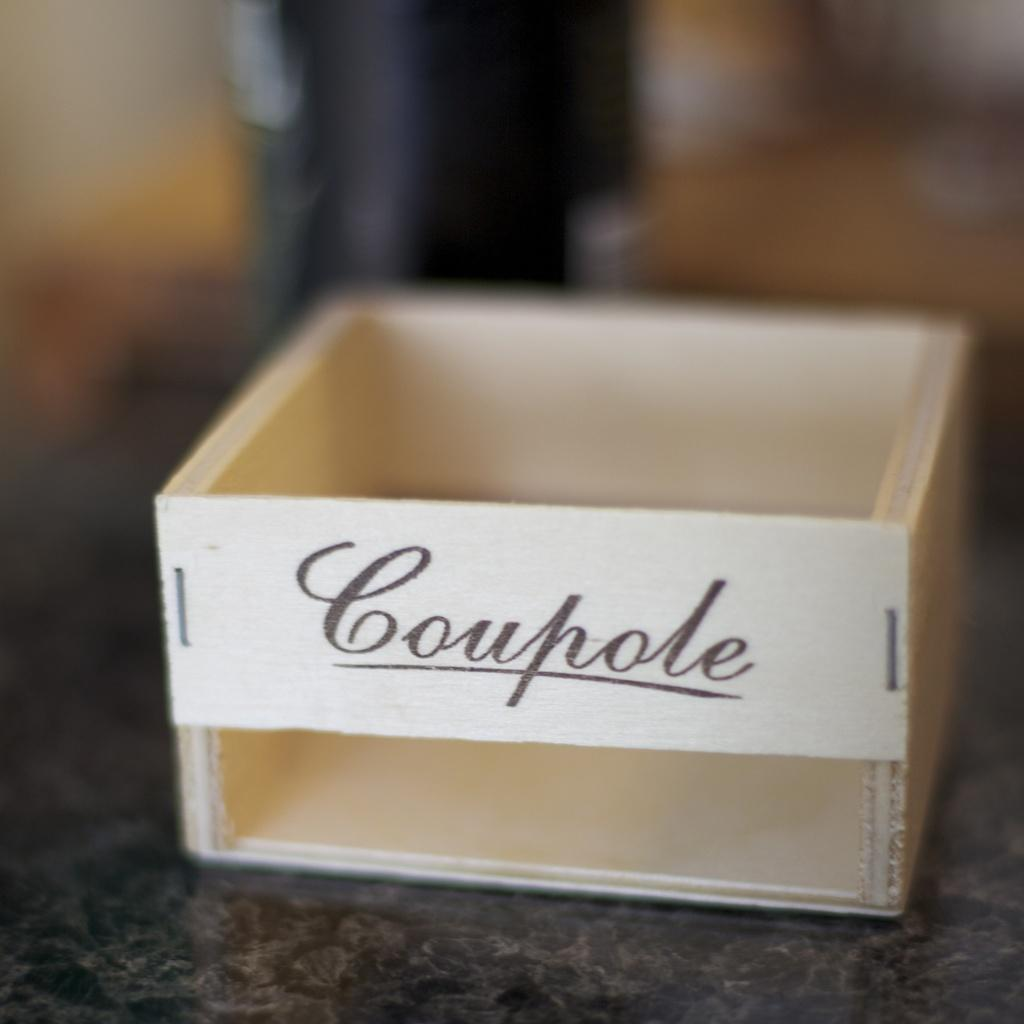Provide a one-sentence caption for the provided image. Small wooden box sitting on a table with a word imprinted on the front. 